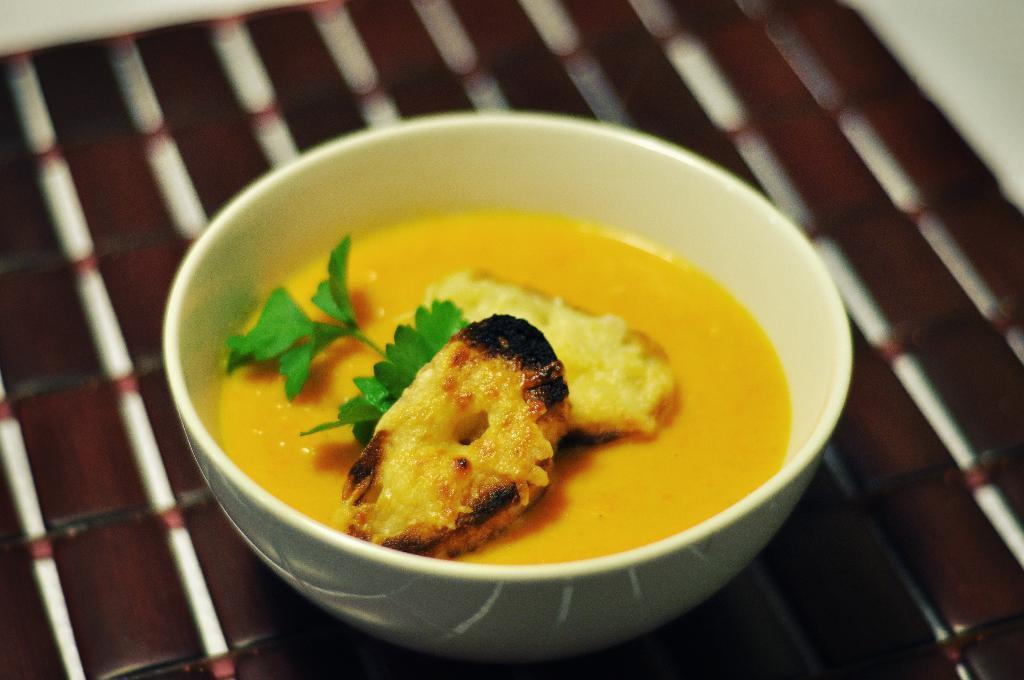In one or two sentences, can you explain what this image depicts? In this image we can see one white bowl with food on the surface which looks like a table. There are two white objects on the top left and right side corner of the image. 